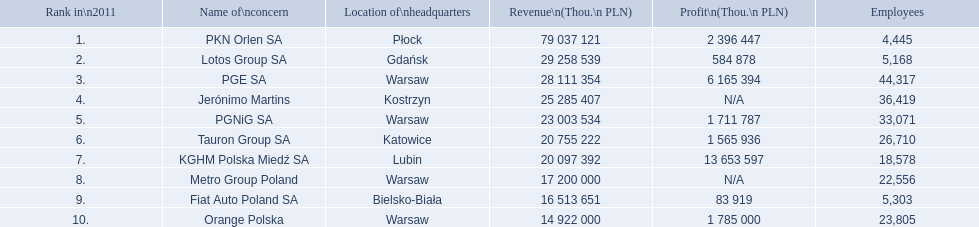How many individuals are employed by pkn orlen sa in poland? 4,445. What is the employee count for lotos group sa? 5,168. What is the total workforce of pgnig sa? 33,071. How many people are employed at pkn orlen sa within poland? 4,445. What is the size of lotos group sa's workforce? 5,168. How many individuals are part of pgnig sa's staff? 33,071. 